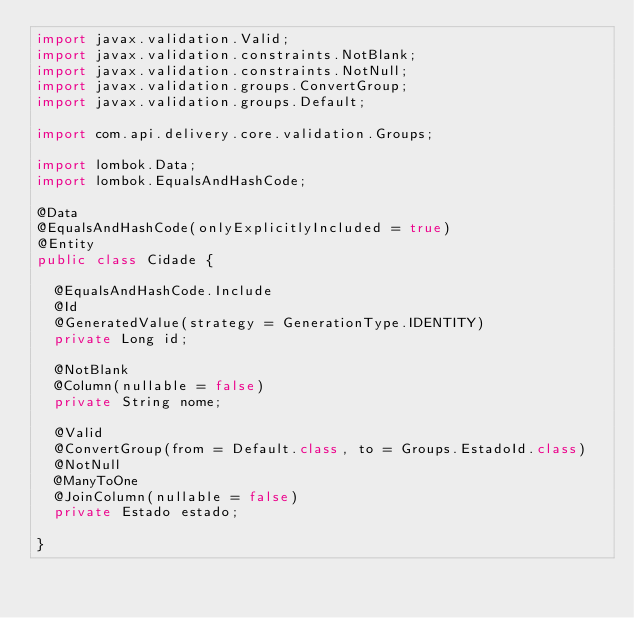<code> <loc_0><loc_0><loc_500><loc_500><_Java_>import javax.validation.Valid;
import javax.validation.constraints.NotBlank;
import javax.validation.constraints.NotNull;
import javax.validation.groups.ConvertGroup;
import javax.validation.groups.Default;

import com.api.delivery.core.validation.Groups;

import lombok.Data;
import lombok.EqualsAndHashCode;

@Data
@EqualsAndHashCode(onlyExplicitlyIncluded = true)
@Entity
public class Cidade {

	@EqualsAndHashCode.Include
	@Id
	@GeneratedValue(strategy = GenerationType.IDENTITY)
	private Long id;
	
	@NotBlank
	@Column(nullable = false)
	private String nome;
	
	@Valid
	@ConvertGroup(from = Default.class, to = Groups.EstadoId.class)
	@NotNull
	@ManyToOne
	@JoinColumn(nullable = false)
	private Estado estado;

}</code> 